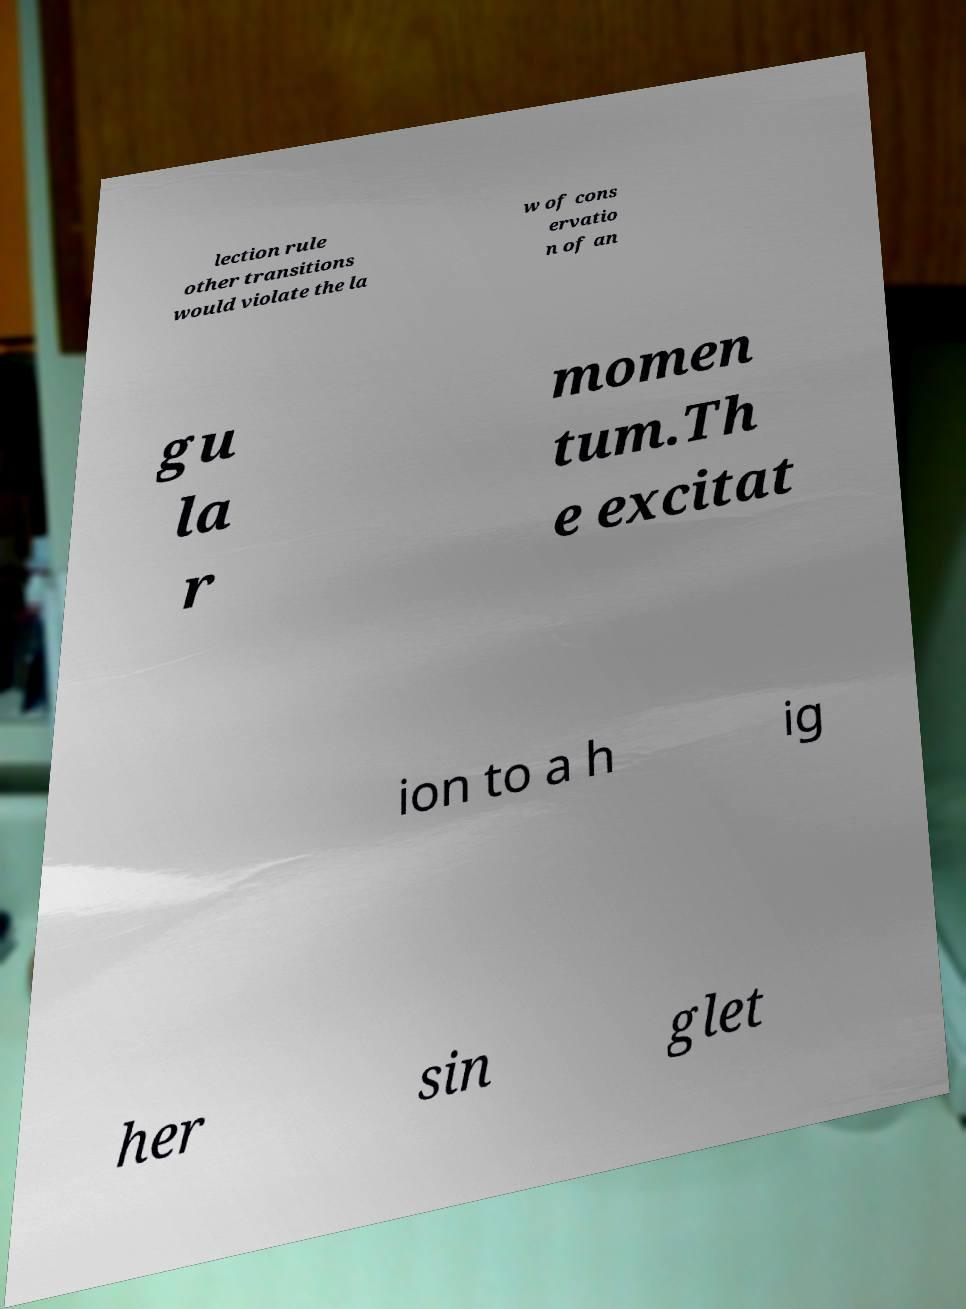What messages or text are displayed in this image? I need them in a readable, typed format. lection rule other transitions would violate the la w of cons ervatio n of an gu la r momen tum.Th e excitat ion to a h ig her sin glet 